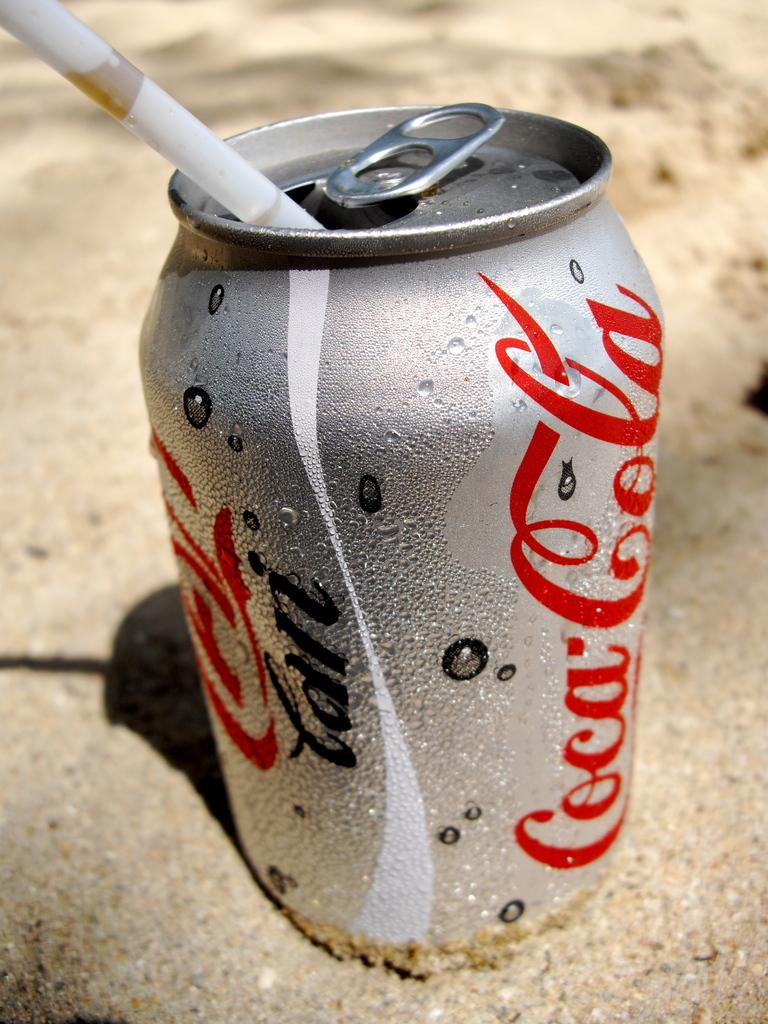<image>
Describe the image concisely. A sweaty silver can of Coca Cola sitting in the sand. 